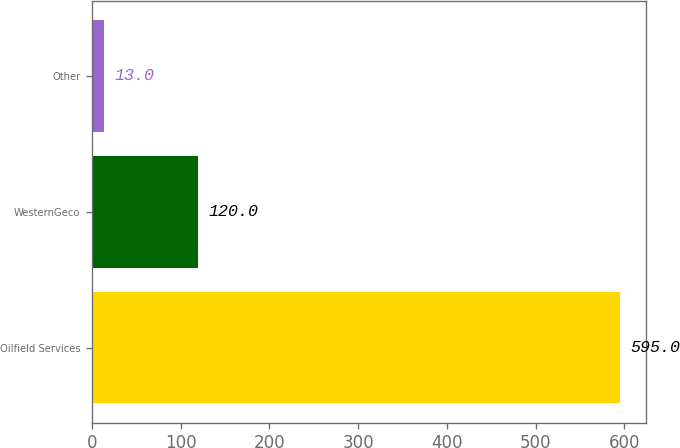<chart> <loc_0><loc_0><loc_500><loc_500><bar_chart><fcel>Oilfield Services<fcel>WesternGeco<fcel>Other<nl><fcel>595<fcel>120<fcel>13<nl></chart> 